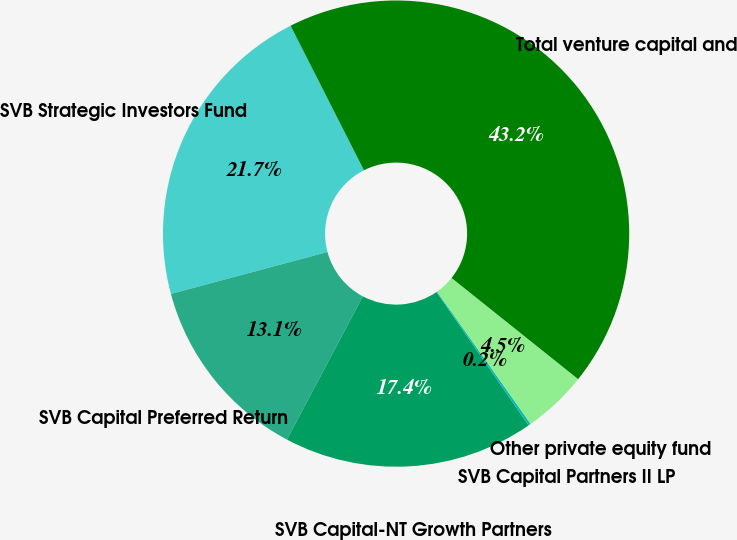Convert chart to OTSL. <chart><loc_0><loc_0><loc_500><loc_500><pie_chart><fcel>SVB Strategic Investors Fund<fcel>SVB Capital Preferred Return<fcel>SVB Capital-NT Growth Partners<fcel>SVB Capital Partners II LP<fcel>Other private equity fund<fcel>Total venture capital and<nl><fcel>21.69%<fcel>13.08%<fcel>17.38%<fcel>0.17%<fcel>4.47%<fcel>43.21%<nl></chart> 